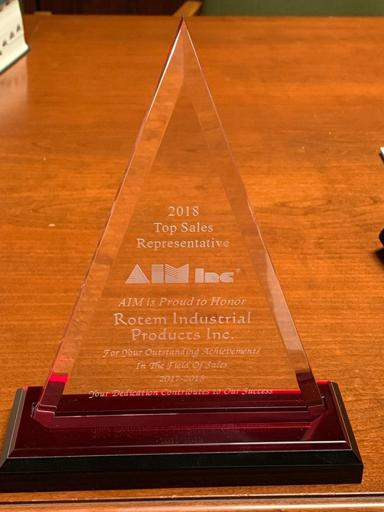What is the design of the glass award in the image? The award features an impressive triangular design signifying growth and upward momentum, characteristic of peak achievements. Its clear glass material captures light beautifully, and it stands on a contrasting dark red base, emphasizing the prestige of the accomplishment. Beyond its geometric shape, the award's design includes bold lettering that commemorates the achievement and the precision of laser engraving that details the recipient and the year of honor. 